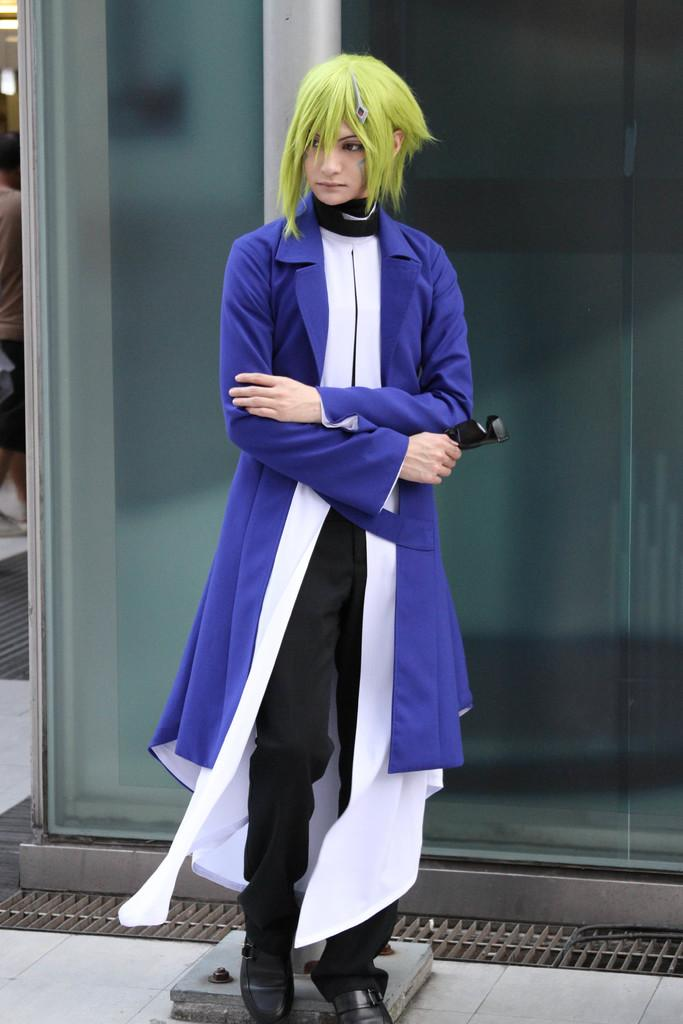What is the main subject of the image? The main subject of the image is a person standing. Can you describe the person's position in the image? The person is standing on the floor. What other object can be seen in the image? There is a pole in the image. What type of wind can be seen blowing the person's mouth in the image? There is no wind present in the image, and therefore no such activity can be observed. What type of cloth is draped over the pole in the image? There is no cloth draped over the pole in the image. 